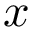<formula> <loc_0><loc_0><loc_500><loc_500>x</formula> 